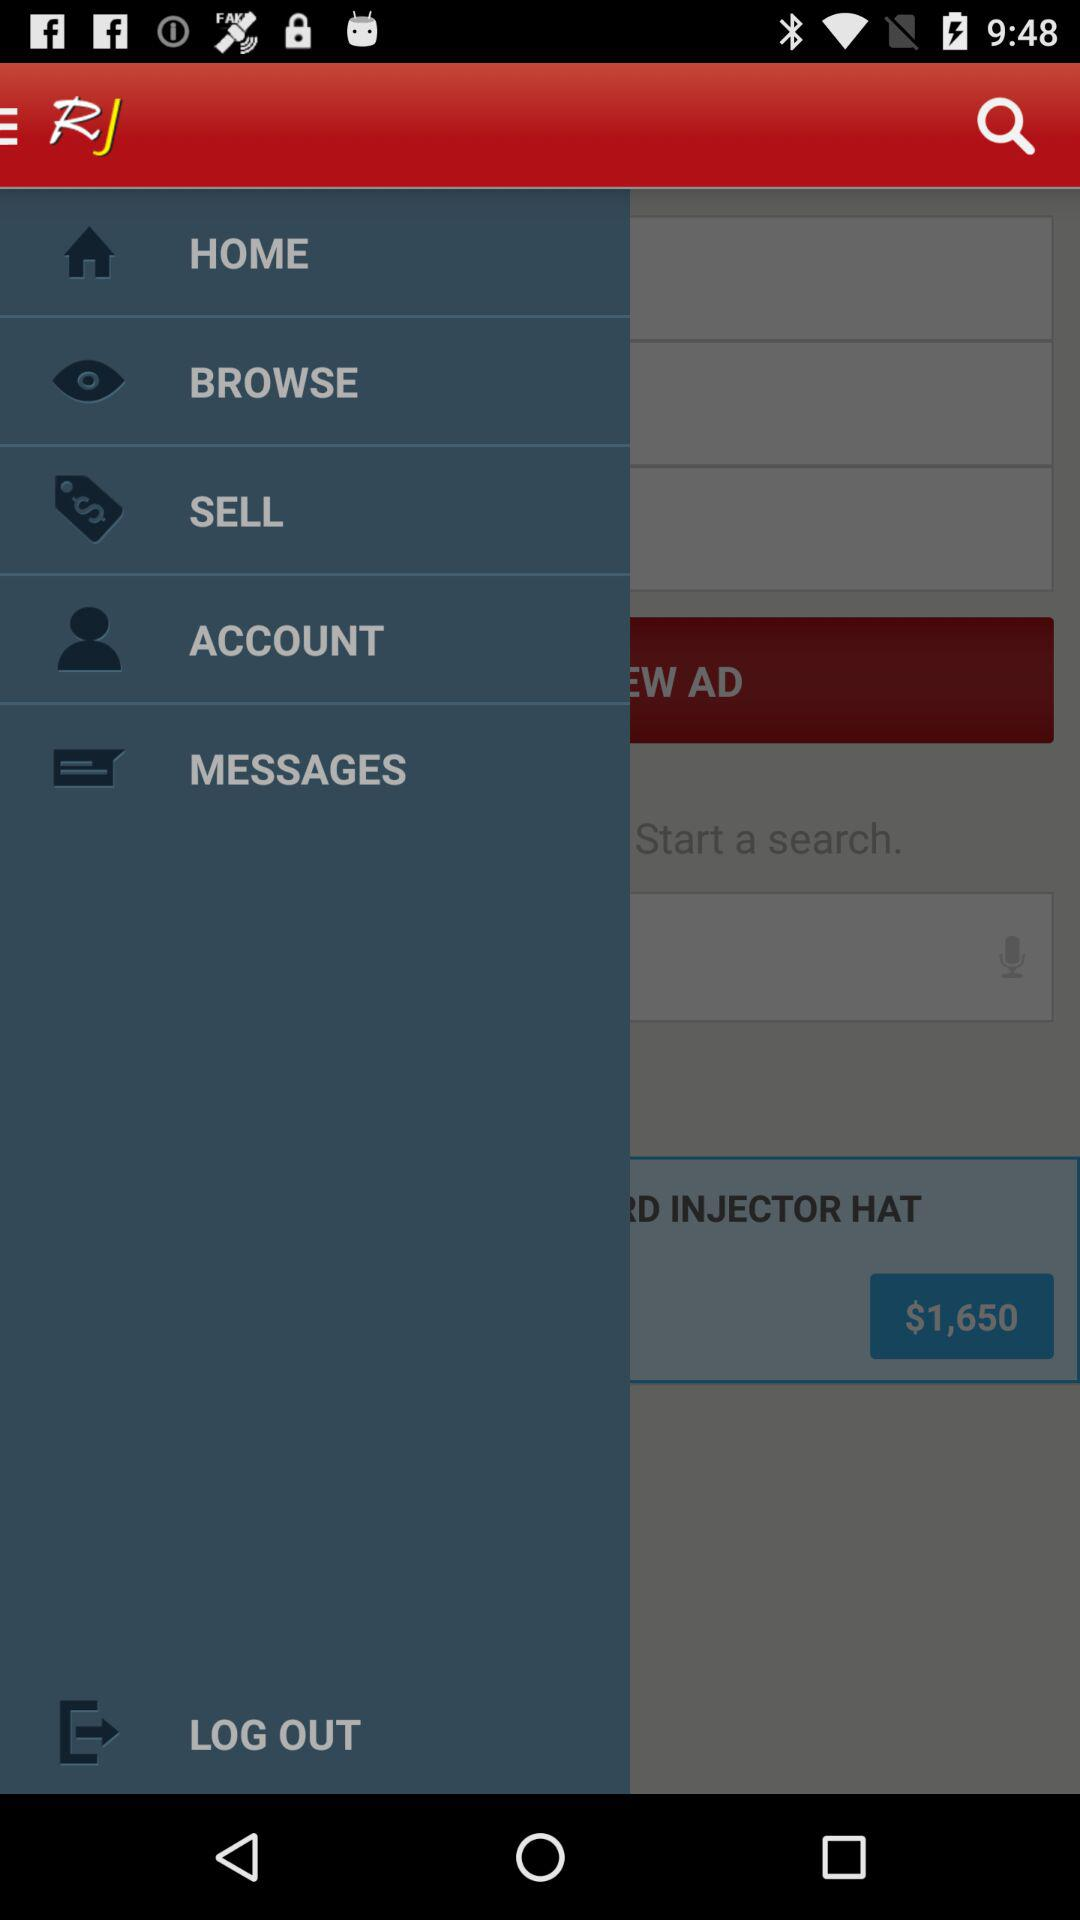What is the name of the application? The name of the application is "Racing Junk Classifieds". 